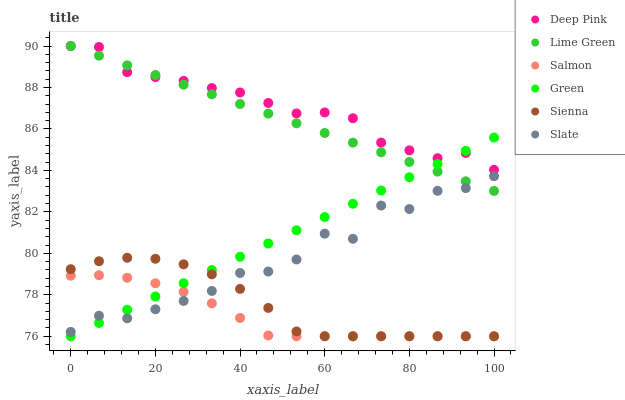Does Salmon have the minimum area under the curve?
Answer yes or no. Yes. Does Deep Pink have the maximum area under the curve?
Answer yes or no. Yes. Does Slate have the minimum area under the curve?
Answer yes or no. No. Does Slate have the maximum area under the curve?
Answer yes or no. No. Is Lime Green the smoothest?
Answer yes or no. Yes. Is Slate the roughest?
Answer yes or no. Yes. Is Salmon the smoothest?
Answer yes or no. No. Is Salmon the roughest?
Answer yes or no. No. Does Salmon have the lowest value?
Answer yes or no. Yes. Does Slate have the lowest value?
Answer yes or no. No. Does Lime Green have the highest value?
Answer yes or no. Yes. Does Slate have the highest value?
Answer yes or no. No. Is Salmon less than Deep Pink?
Answer yes or no. Yes. Is Lime Green greater than Sienna?
Answer yes or no. Yes. Does Slate intersect Sienna?
Answer yes or no. Yes. Is Slate less than Sienna?
Answer yes or no. No. Is Slate greater than Sienna?
Answer yes or no. No. Does Salmon intersect Deep Pink?
Answer yes or no. No. 